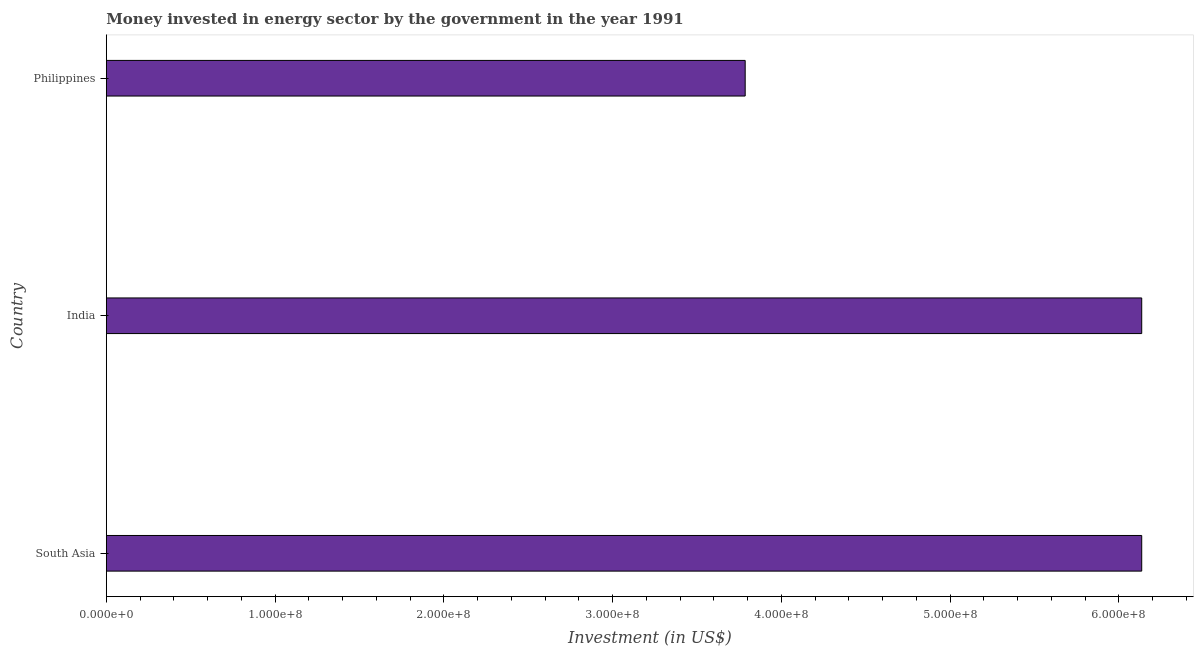What is the title of the graph?
Make the answer very short. Money invested in energy sector by the government in the year 1991. What is the label or title of the X-axis?
Make the answer very short. Investment (in US$). What is the investment in energy in India?
Ensure brevity in your answer.  6.14e+08. Across all countries, what is the maximum investment in energy?
Your answer should be very brief. 6.14e+08. Across all countries, what is the minimum investment in energy?
Keep it short and to the point. 3.79e+08. In which country was the investment in energy maximum?
Make the answer very short. South Asia. In which country was the investment in energy minimum?
Your response must be concise. Philippines. What is the sum of the investment in energy?
Ensure brevity in your answer.  1.61e+09. What is the difference between the investment in energy in Philippines and South Asia?
Offer a terse response. -2.35e+08. What is the average investment in energy per country?
Offer a very short reply. 5.35e+08. What is the median investment in energy?
Your answer should be compact. 6.14e+08. In how many countries, is the investment in energy greater than 120000000 US$?
Your answer should be very brief. 3. What is the ratio of the investment in energy in India to that in Philippines?
Your answer should be very brief. 1.62. Is the investment in energy in India less than that in Philippines?
Make the answer very short. No. Is the sum of the investment in energy in India and South Asia greater than the maximum investment in energy across all countries?
Offer a very short reply. Yes. What is the difference between the highest and the lowest investment in energy?
Make the answer very short. 2.35e+08. In how many countries, is the investment in energy greater than the average investment in energy taken over all countries?
Ensure brevity in your answer.  2. Are all the bars in the graph horizontal?
Make the answer very short. Yes. How many countries are there in the graph?
Ensure brevity in your answer.  3. What is the difference between two consecutive major ticks on the X-axis?
Your answer should be very brief. 1.00e+08. What is the Investment (in US$) of South Asia?
Your answer should be compact. 6.14e+08. What is the Investment (in US$) of India?
Provide a succinct answer. 6.14e+08. What is the Investment (in US$) of Philippines?
Keep it short and to the point. 3.79e+08. What is the difference between the Investment (in US$) in South Asia and India?
Ensure brevity in your answer.  0. What is the difference between the Investment (in US$) in South Asia and Philippines?
Offer a terse response. 2.35e+08. What is the difference between the Investment (in US$) in India and Philippines?
Ensure brevity in your answer.  2.35e+08. What is the ratio of the Investment (in US$) in South Asia to that in India?
Offer a very short reply. 1. What is the ratio of the Investment (in US$) in South Asia to that in Philippines?
Your response must be concise. 1.62. What is the ratio of the Investment (in US$) in India to that in Philippines?
Keep it short and to the point. 1.62. 